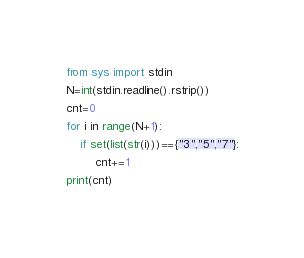<code> <loc_0><loc_0><loc_500><loc_500><_Python_>from sys import stdin
N=int(stdin.readline().rstrip())
cnt=0
for i in range(N+1):
    if set(list(str(i)))=={"3","5","7"}:
        cnt+=1
print(cnt)</code> 